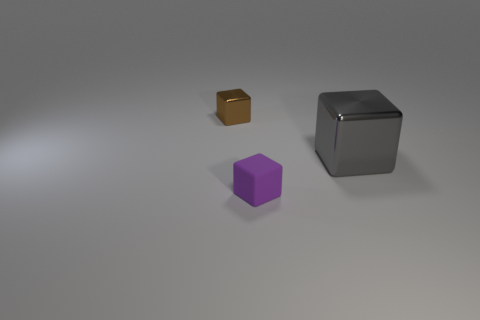Is the material of the gray block the same as the tiny object in front of the big thing?
Give a very brief answer. No. What number of other things are the same color as the rubber cube?
Offer a terse response. 0. Is the number of small brown objects that are in front of the brown metal cube the same as the number of big gray metal blocks?
Your answer should be very brief. No. There is a small cube that is left of the tiny purple cube left of the gray metal cube; how many purple matte things are in front of it?
Provide a succinct answer. 1. Are there any other things that have the same size as the gray block?
Provide a succinct answer. No. There is a brown shiny cube; is it the same size as the thing to the right of the tiny purple cube?
Keep it short and to the point. No. How many blue blocks are there?
Keep it short and to the point. 0. There is a cube on the left side of the purple thing; is it the same size as the shiny block in front of the brown metallic object?
Your answer should be very brief. No. The other large object that is the same shape as the brown object is what color?
Provide a short and direct response. Gray. Does the big gray thing have the same shape as the brown metal object?
Ensure brevity in your answer.  Yes. 